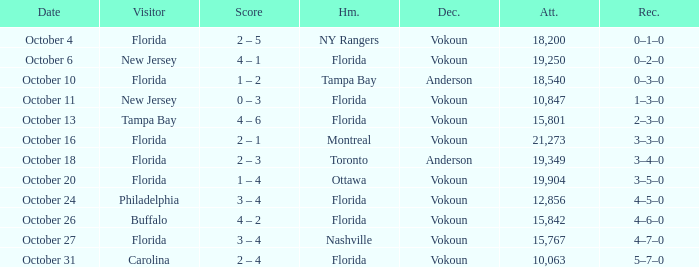What was the score on October 31? 2 – 4. 